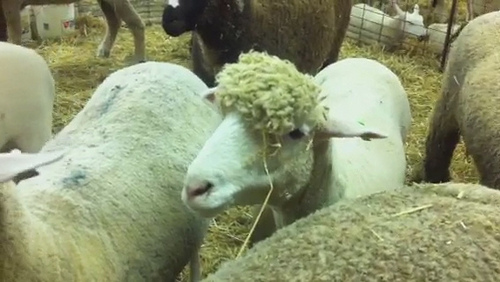What are the sheep doing in this picture? The sheep are mostly standing and some are grazing on the hay. One sheep in the foreground seems to be chewing on a piece of straw, giving a sense of their natural and relaxed behavior in this farm setting. 